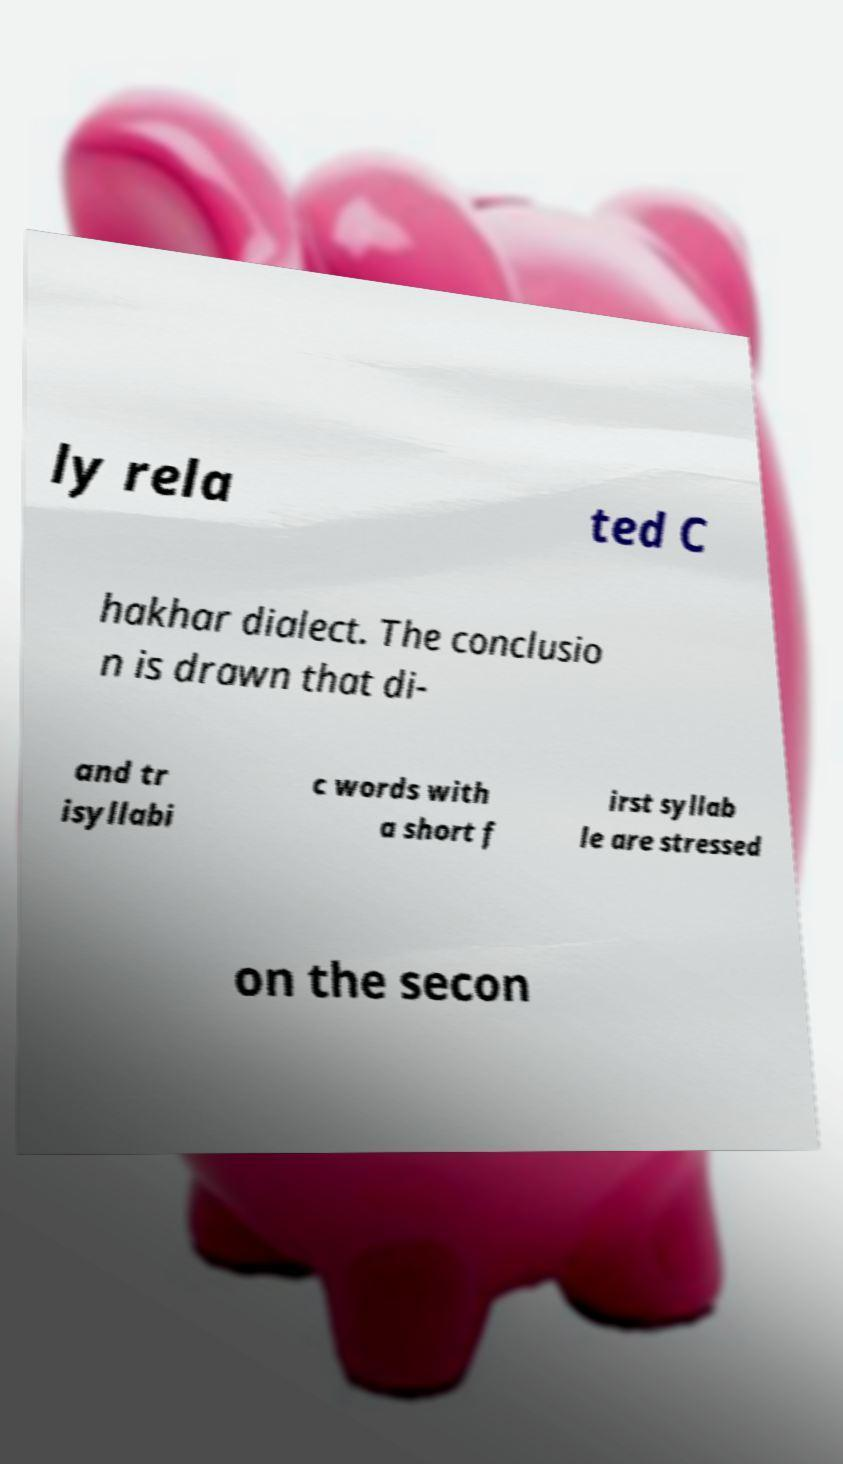Please identify and transcribe the text found in this image. ly rela ted C hakhar dialect. The conclusio n is drawn that di- and tr isyllabi c words with a short f irst syllab le are stressed on the secon 